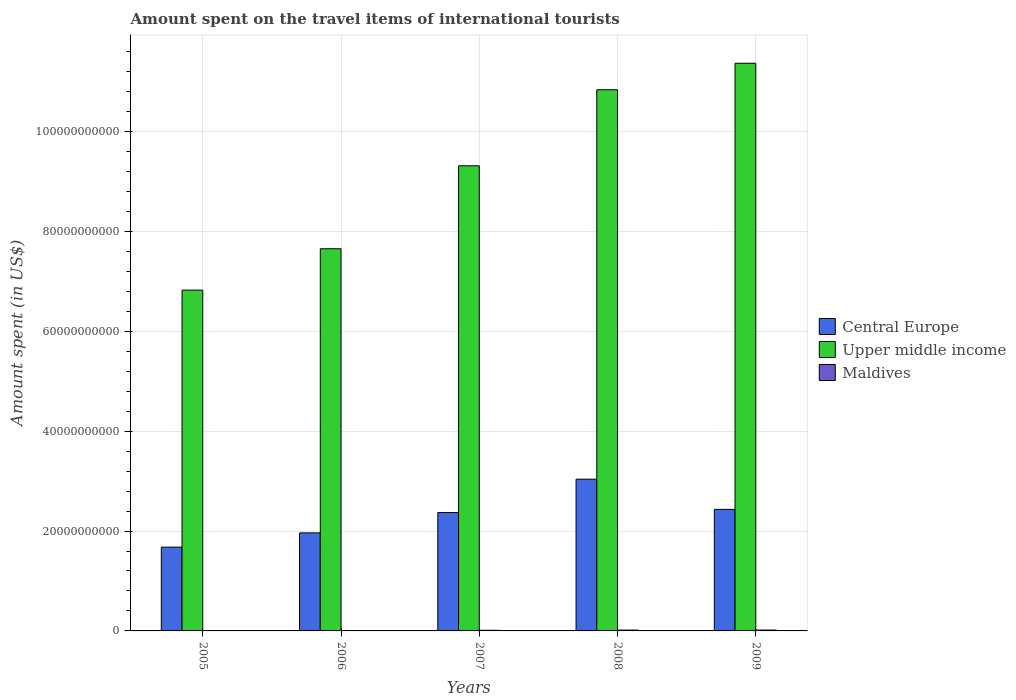How many different coloured bars are there?
Provide a succinct answer. 3. How many groups of bars are there?
Make the answer very short. 5. What is the amount spent on the travel items of international tourists in Central Europe in 2006?
Give a very brief answer. 1.96e+1. Across all years, what is the maximum amount spent on the travel items of international tourists in Maldives?
Keep it short and to the point. 1.74e+08. Across all years, what is the minimum amount spent on the travel items of international tourists in Upper middle income?
Offer a very short reply. 6.82e+1. In which year was the amount spent on the travel items of international tourists in Central Europe minimum?
Offer a terse response. 2005. What is the total amount spent on the travel items of international tourists in Upper middle income in the graph?
Your answer should be very brief. 4.60e+11. What is the difference between the amount spent on the travel items of international tourists in Upper middle income in 2008 and that in 2009?
Keep it short and to the point. -5.30e+09. What is the difference between the amount spent on the travel items of international tourists in Upper middle income in 2005 and the amount spent on the travel items of international tourists in Central Europe in 2009?
Offer a very short reply. 4.39e+1. What is the average amount spent on the travel items of international tourists in Maldives per year?
Provide a short and direct response. 1.22e+08. In the year 2009, what is the difference between the amount spent on the travel items of international tourists in Maldives and amount spent on the travel items of international tourists in Central Europe?
Offer a very short reply. -2.42e+1. In how many years, is the amount spent on the travel items of international tourists in Upper middle income greater than 96000000000 US$?
Give a very brief answer. 2. What is the ratio of the amount spent on the travel items of international tourists in Maldives in 2006 to that in 2008?
Offer a very short reply. 0.47. Is the amount spent on the travel items of international tourists in Upper middle income in 2006 less than that in 2007?
Your answer should be very brief. Yes. What is the difference between the highest and the lowest amount spent on the travel items of international tourists in Upper middle income?
Ensure brevity in your answer.  4.54e+1. Is the sum of the amount spent on the travel items of international tourists in Central Europe in 2006 and 2009 greater than the maximum amount spent on the travel items of international tourists in Upper middle income across all years?
Provide a short and direct response. No. What does the 2nd bar from the left in 2009 represents?
Your answer should be compact. Upper middle income. What does the 3rd bar from the right in 2006 represents?
Keep it short and to the point. Central Europe. Is it the case that in every year, the sum of the amount spent on the travel items of international tourists in Central Europe and amount spent on the travel items of international tourists in Maldives is greater than the amount spent on the travel items of international tourists in Upper middle income?
Provide a short and direct response. No. How many bars are there?
Keep it short and to the point. 15. Are all the bars in the graph horizontal?
Your response must be concise. No. How many years are there in the graph?
Ensure brevity in your answer.  5. What is the difference between two consecutive major ticks on the Y-axis?
Your answer should be compact. 2.00e+1. Are the values on the major ticks of Y-axis written in scientific E-notation?
Provide a succinct answer. No. Does the graph contain grids?
Provide a succinct answer. Yes. What is the title of the graph?
Keep it short and to the point. Amount spent on the travel items of international tourists. Does "Arab World" appear as one of the legend labels in the graph?
Make the answer very short. No. What is the label or title of the X-axis?
Your answer should be very brief. Years. What is the label or title of the Y-axis?
Make the answer very short. Amount spent (in US$). What is the Amount spent (in US$) of Central Europe in 2005?
Keep it short and to the point. 1.68e+1. What is the Amount spent (in US$) of Upper middle income in 2005?
Your response must be concise. 6.82e+1. What is the Amount spent (in US$) in Maldives in 2005?
Offer a terse response. 7.00e+07. What is the Amount spent (in US$) of Central Europe in 2006?
Your answer should be very brief. 1.96e+1. What is the Amount spent (in US$) in Upper middle income in 2006?
Your response must be concise. 7.65e+1. What is the Amount spent (in US$) of Maldives in 2006?
Provide a short and direct response. 7.80e+07. What is the Amount spent (in US$) of Central Europe in 2007?
Ensure brevity in your answer.  2.37e+1. What is the Amount spent (in US$) of Upper middle income in 2007?
Make the answer very short. 9.31e+1. What is the Amount spent (in US$) of Maldives in 2007?
Your answer should be very brief. 1.22e+08. What is the Amount spent (in US$) in Central Europe in 2008?
Give a very brief answer. 3.04e+1. What is the Amount spent (in US$) of Upper middle income in 2008?
Offer a very short reply. 1.08e+11. What is the Amount spent (in US$) in Maldives in 2008?
Ensure brevity in your answer.  1.67e+08. What is the Amount spent (in US$) in Central Europe in 2009?
Your answer should be compact. 2.43e+1. What is the Amount spent (in US$) in Upper middle income in 2009?
Provide a succinct answer. 1.14e+11. What is the Amount spent (in US$) of Maldives in 2009?
Your answer should be compact. 1.74e+08. Across all years, what is the maximum Amount spent (in US$) in Central Europe?
Provide a succinct answer. 3.04e+1. Across all years, what is the maximum Amount spent (in US$) in Upper middle income?
Provide a short and direct response. 1.14e+11. Across all years, what is the maximum Amount spent (in US$) of Maldives?
Ensure brevity in your answer.  1.74e+08. Across all years, what is the minimum Amount spent (in US$) in Central Europe?
Make the answer very short. 1.68e+1. Across all years, what is the minimum Amount spent (in US$) in Upper middle income?
Keep it short and to the point. 6.82e+1. Across all years, what is the minimum Amount spent (in US$) of Maldives?
Ensure brevity in your answer.  7.00e+07. What is the total Amount spent (in US$) of Central Europe in the graph?
Provide a succinct answer. 1.15e+11. What is the total Amount spent (in US$) in Upper middle income in the graph?
Provide a short and direct response. 4.60e+11. What is the total Amount spent (in US$) in Maldives in the graph?
Offer a very short reply. 6.11e+08. What is the difference between the Amount spent (in US$) of Central Europe in 2005 and that in 2006?
Keep it short and to the point. -2.85e+09. What is the difference between the Amount spent (in US$) in Upper middle income in 2005 and that in 2006?
Keep it short and to the point. -8.28e+09. What is the difference between the Amount spent (in US$) in Maldives in 2005 and that in 2006?
Your answer should be compact. -8.00e+06. What is the difference between the Amount spent (in US$) in Central Europe in 2005 and that in 2007?
Offer a terse response. -6.92e+09. What is the difference between the Amount spent (in US$) in Upper middle income in 2005 and that in 2007?
Provide a short and direct response. -2.49e+1. What is the difference between the Amount spent (in US$) of Maldives in 2005 and that in 2007?
Provide a succinct answer. -5.20e+07. What is the difference between the Amount spent (in US$) of Central Europe in 2005 and that in 2008?
Your answer should be compact. -1.36e+1. What is the difference between the Amount spent (in US$) of Upper middle income in 2005 and that in 2008?
Your answer should be very brief. -4.01e+1. What is the difference between the Amount spent (in US$) of Maldives in 2005 and that in 2008?
Your answer should be compact. -9.70e+07. What is the difference between the Amount spent (in US$) in Central Europe in 2005 and that in 2009?
Your answer should be very brief. -7.56e+09. What is the difference between the Amount spent (in US$) of Upper middle income in 2005 and that in 2009?
Your answer should be compact. -4.54e+1. What is the difference between the Amount spent (in US$) of Maldives in 2005 and that in 2009?
Provide a short and direct response. -1.04e+08. What is the difference between the Amount spent (in US$) in Central Europe in 2006 and that in 2007?
Give a very brief answer. -4.08e+09. What is the difference between the Amount spent (in US$) of Upper middle income in 2006 and that in 2007?
Offer a terse response. -1.66e+1. What is the difference between the Amount spent (in US$) in Maldives in 2006 and that in 2007?
Your answer should be compact. -4.40e+07. What is the difference between the Amount spent (in US$) in Central Europe in 2006 and that in 2008?
Your response must be concise. -1.08e+1. What is the difference between the Amount spent (in US$) of Upper middle income in 2006 and that in 2008?
Your answer should be compact. -3.18e+1. What is the difference between the Amount spent (in US$) in Maldives in 2006 and that in 2008?
Your answer should be very brief. -8.90e+07. What is the difference between the Amount spent (in US$) in Central Europe in 2006 and that in 2009?
Your answer should be very brief. -4.71e+09. What is the difference between the Amount spent (in US$) of Upper middle income in 2006 and that in 2009?
Provide a short and direct response. -3.71e+1. What is the difference between the Amount spent (in US$) in Maldives in 2006 and that in 2009?
Give a very brief answer. -9.60e+07. What is the difference between the Amount spent (in US$) of Central Europe in 2007 and that in 2008?
Your answer should be very brief. -6.68e+09. What is the difference between the Amount spent (in US$) in Upper middle income in 2007 and that in 2008?
Provide a short and direct response. -1.52e+1. What is the difference between the Amount spent (in US$) of Maldives in 2007 and that in 2008?
Your answer should be compact. -4.50e+07. What is the difference between the Amount spent (in US$) of Central Europe in 2007 and that in 2009?
Your answer should be very brief. -6.36e+08. What is the difference between the Amount spent (in US$) of Upper middle income in 2007 and that in 2009?
Your answer should be compact. -2.05e+1. What is the difference between the Amount spent (in US$) in Maldives in 2007 and that in 2009?
Your response must be concise. -5.20e+07. What is the difference between the Amount spent (in US$) in Central Europe in 2008 and that in 2009?
Your response must be concise. 6.05e+09. What is the difference between the Amount spent (in US$) in Upper middle income in 2008 and that in 2009?
Offer a terse response. -5.30e+09. What is the difference between the Amount spent (in US$) of Maldives in 2008 and that in 2009?
Make the answer very short. -7.00e+06. What is the difference between the Amount spent (in US$) of Central Europe in 2005 and the Amount spent (in US$) of Upper middle income in 2006?
Give a very brief answer. -5.97e+1. What is the difference between the Amount spent (in US$) of Central Europe in 2005 and the Amount spent (in US$) of Maldives in 2006?
Provide a succinct answer. 1.67e+1. What is the difference between the Amount spent (in US$) of Upper middle income in 2005 and the Amount spent (in US$) of Maldives in 2006?
Provide a succinct answer. 6.82e+1. What is the difference between the Amount spent (in US$) in Central Europe in 2005 and the Amount spent (in US$) in Upper middle income in 2007?
Keep it short and to the point. -7.64e+1. What is the difference between the Amount spent (in US$) of Central Europe in 2005 and the Amount spent (in US$) of Maldives in 2007?
Give a very brief answer. 1.67e+1. What is the difference between the Amount spent (in US$) in Upper middle income in 2005 and the Amount spent (in US$) in Maldives in 2007?
Your answer should be very brief. 6.81e+1. What is the difference between the Amount spent (in US$) of Central Europe in 2005 and the Amount spent (in US$) of Upper middle income in 2008?
Your answer should be very brief. -9.16e+1. What is the difference between the Amount spent (in US$) of Central Europe in 2005 and the Amount spent (in US$) of Maldives in 2008?
Your answer should be very brief. 1.66e+1. What is the difference between the Amount spent (in US$) of Upper middle income in 2005 and the Amount spent (in US$) of Maldives in 2008?
Your answer should be compact. 6.81e+1. What is the difference between the Amount spent (in US$) in Central Europe in 2005 and the Amount spent (in US$) in Upper middle income in 2009?
Offer a terse response. -9.69e+1. What is the difference between the Amount spent (in US$) of Central Europe in 2005 and the Amount spent (in US$) of Maldives in 2009?
Offer a terse response. 1.66e+1. What is the difference between the Amount spent (in US$) in Upper middle income in 2005 and the Amount spent (in US$) in Maldives in 2009?
Keep it short and to the point. 6.81e+1. What is the difference between the Amount spent (in US$) in Central Europe in 2006 and the Amount spent (in US$) in Upper middle income in 2007?
Your answer should be compact. -7.35e+1. What is the difference between the Amount spent (in US$) of Central Europe in 2006 and the Amount spent (in US$) of Maldives in 2007?
Your answer should be compact. 1.95e+1. What is the difference between the Amount spent (in US$) of Upper middle income in 2006 and the Amount spent (in US$) of Maldives in 2007?
Provide a succinct answer. 7.64e+1. What is the difference between the Amount spent (in US$) in Central Europe in 2006 and the Amount spent (in US$) in Upper middle income in 2008?
Ensure brevity in your answer.  -8.87e+1. What is the difference between the Amount spent (in US$) of Central Europe in 2006 and the Amount spent (in US$) of Maldives in 2008?
Offer a very short reply. 1.95e+1. What is the difference between the Amount spent (in US$) of Upper middle income in 2006 and the Amount spent (in US$) of Maldives in 2008?
Offer a very short reply. 7.64e+1. What is the difference between the Amount spent (in US$) in Central Europe in 2006 and the Amount spent (in US$) in Upper middle income in 2009?
Your answer should be compact. -9.40e+1. What is the difference between the Amount spent (in US$) of Central Europe in 2006 and the Amount spent (in US$) of Maldives in 2009?
Provide a short and direct response. 1.95e+1. What is the difference between the Amount spent (in US$) in Upper middle income in 2006 and the Amount spent (in US$) in Maldives in 2009?
Your answer should be very brief. 7.63e+1. What is the difference between the Amount spent (in US$) of Central Europe in 2007 and the Amount spent (in US$) of Upper middle income in 2008?
Provide a succinct answer. -8.47e+1. What is the difference between the Amount spent (in US$) in Central Europe in 2007 and the Amount spent (in US$) in Maldives in 2008?
Provide a short and direct response. 2.35e+1. What is the difference between the Amount spent (in US$) of Upper middle income in 2007 and the Amount spent (in US$) of Maldives in 2008?
Provide a succinct answer. 9.30e+1. What is the difference between the Amount spent (in US$) of Central Europe in 2007 and the Amount spent (in US$) of Upper middle income in 2009?
Offer a terse response. -9.00e+1. What is the difference between the Amount spent (in US$) in Central Europe in 2007 and the Amount spent (in US$) in Maldives in 2009?
Your response must be concise. 2.35e+1. What is the difference between the Amount spent (in US$) of Upper middle income in 2007 and the Amount spent (in US$) of Maldives in 2009?
Offer a terse response. 9.30e+1. What is the difference between the Amount spent (in US$) in Central Europe in 2008 and the Amount spent (in US$) in Upper middle income in 2009?
Provide a succinct answer. -8.33e+1. What is the difference between the Amount spent (in US$) in Central Europe in 2008 and the Amount spent (in US$) in Maldives in 2009?
Provide a short and direct response. 3.02e+1. What is the difference between the Amount spent (in US$) in Upper middle income in 2008 and the Amount spent (in US$) in Maldives in 2009?
Your response must be concise. 1.08e+11. What is the average Amount spent (in US$) in Central Europe per year?
Make the answer very short. 2.30e+1. What is the average Amount spent (in US$) of Upper middle income per year?
Offer a very short reply. 9.20e+1. What is the average Amount spent (in US$) of Maldives per year?
Your answer should be very brief. 1.22e+08. In the year 2005, what is the difference between the Amount spent (in US$) in Central Europe and Amount spent (in US$) in Upper middle income?
Keep it short and to the point. -5.15e+1. In the year 2005, what is the difference between the Amount spent (in US$) in Central Europe and Amount spent (in US$) in Maldives?
Offer a very short reply. 1.67e+1. In the year 2005, what is the difference between the Amount spent (in US$) in Upper middle income and Amount spent (in US$) in Maldives?
Your answer should be very brief. 6.82e+1. In the year 2006, what is the difference between the Amount spent (in US$) in Central Europe and Amount spent (in US$) in Upper middle income?
Offer a very short reply. -5.69e+1. In the year 2006, what is the difference between the Amount spent (in US$) of Central Europe and Amount spent (in US$) of Maldives?
Provide a succinct answer. 1.95e+1. In the year 2006, what is the difference between the Amount spent (in US$) of Upper middle income and Amount spent (in US$) of Maldives?
Provide a succinct answer. 7.64e+1. In the year 2007, what is the difference between the Amount spent (in US$) of Central Europe and Amount spent (in US$) of Upper middle income?
Provide a short and direct response. -6.94e+1. In the year 2007, what is the difference between the Amount spent (in US$) of Central Europe and Amount spent (in US$) of Maldives?
Your response must be concise. 2.36e+1. In the year 2007, what is the difference between the Amount spent (in US$) of Upper middle income and Amount spent (in US$) of Maldives?
Your response must be concise. 9.30e+1. In the year 2008, what is the difference between the Amount spent (in US$) of Central Europe and Amount spent (in US$) of Upper middle income?
Give a very brief answer. -7.80e+1. In the year 2008, what is the difference between the Amount spent (in US$) of Central Europe and Amount spent (in US$) of Maldives?
Your response must be concise. 3.02e+1. In the year 2008, what is the difference between the Amount spent (in US$) in Upper middle income and Amount spent (in US$) in Maldives?
Offer a terse response. 1.08e+11. In the year 2009, what is the difference between the Amount spent (in US$) in Central Europe and Amount spent (in US$) in Upper middle income?
Keep it short and to the point. -8.93e+1. In the year 2009, what is the difference between the Amount spent (in US$) in Central Europe and Amount spent (in US$) in Maldives?
Provide a short and direct response. 2.42e+1. In the year 2009, what is the difference between the Amount spent (in US$) of Upper middle income and Amount spent (in US$) of Maldives?
Ensure brevity in your answer.  1.13e+11. What is the ratio of the Amount spent (in US$) of Central Europe in 2005 to that in 2006?
Your answer should be very brief. 0.85. What is the ratio of the Amount spent (in US$) of Upper middle income in 2005 to that in 2006?
Keep it short and to the point. 0.89. What is the ratio of the Amount spent (in US$) in Maldives in 2005 to that in 2006?
Offer a very short reply. 0.9. What is the ratio of the Amount spent (in US$) in Central Europe in 2005 to that in 2007?
Your answer should be compact. 0.71. What is the ratio of the Amount spent (in US$) in Upper middle income in 2005 to that in 2007?
Your answer should be compact. 0.73. What is the ratio of the Amount spent (in US$) in Maldives in 2005 to that in 2007?
Offer a very short reply. 0.57. What is the ratio of the Amount spent (in US$) in Central Europe in 2005 to that in 2008?
Provide a succinct answer. 0.55. What is the ratio of the Amount spent (in US$) of Upper middle income in 2005 to that in 2008?
Keep it short and to the point. 0.63. What is the ratio of the Amount spent (in US$) of Maldives in 2005 to that in 2008?
Provide a short and direct response. 0.42. What is the ratio of the Amount spent (in US$) in Central Europe in 2005 to that in 2009?
Provide a succinct answer. 0.69. What is the ratio of the Amount spent (in US$) of Upper middle income in 2005 to that in 2009?
Make the answer very short. 0.6. What is the ratio of the Amount spent (in US$) of Maldives in 2005 to that in 2009?
Your answer should be very brief. 0.4. What is the ratio of the Amount spent (in US$) of Central Europe in 2006 to that in 2007?
Your response must be concise. 0.83. What is the ratio of the Amount spent (in US$) of Upper middle income in 2006 to that in 2007?
Keep it short and to the point. 0.82. What is the ratio of the Amount spent (in US$) of Maldives in 2006 to that in 2007?
Keep it short and to the point. 0.64. What is the ratio of the Amount spent (in US$) of Central Europe in 2006 to that in 2008?
Ensure brevity in your answer.  0.65. What is the ratio of the Amount spent (in US$) of Upper middle income in 2006 to that in 2008?
Your response must be concise. 0.71. What is the ratio of the Amount spent (in US$) of Maldives in 2006 to that in 2008?
Ensure brevity in your answer.  0.47. What is the ratio of the Amount spent (in US$) of Central Europe in 2006 to that in 2009?
Provide a short and direct response. 0.81. What is the ratio of the Amount spent (in US$) of Upper middle income in 2006 to that in 2009?
Your answer should be very brief. 0.67. What is the ratio of the Amount spent (in US$) of Maldives in 2006 to that in 2009?
Make the answer very short. 0.45. What is the ratio of the Amount spent (in US$) in Central Europe in 2007 to that in 2008?
Keep it short and to the point. 0.78. What is the ratio of the Amount spent (in US$) in Upper middle income in 2007 to that in 2008?
Your response must be concise. 0.86. What is the ratio of the Amount spent (in US$) in Maldives in 2007 to that in 2008?
Keep it short and to the point. 0.73. What is the ratio of the Amount spent (in US$) in Central Europe in 2007 to that in 2009?
Your answer should be very brief. 0.97. What is the ratio of the Amount spent (in US$) in Upper middle income in 2007 to that in 2009?
Give a very brief answer. 0.82. What is the ratio of the Amount spent (in US$) in Maldives in 2007 to that in 2009?
Your answer should be compact. 0.7. What is the ratio of the Amount spent (in US$) of Central Europe in 2008 to that in 2009?
Ensure brevity in your answer.  1.25. What is the ratio of the Amount spent (in US$) in Upper middle income in 2008 to that in 2009?
Offer a terse response. 0.95. What is the ratio of the Amount spent (in US$) of Maldives in 2008 to that in 2009?
Give a very brief answer. 0.96. What is the difference between the highest and the second highest Amount spent (in US$) of Central Europe?
Your answer should be compact. 6.05e+09. What is the difference between the highest and the second highest Amount spent (in US$) of Upper middle income?
Your response must be concise. 5.30e+09. What is the difference between the highest and the second highest Amount spent (in US$) of Maldives?
Offer a very short reply. 7.00e+06. What is the difference between the highest and the lowest Amount spent (in US$) in Central Europe?
Provide a short and direct response. 1.36e+1. What is the difference between the highest and the lowest Amount spent (in US$) in Upper middle income?
Provide a short and direct response. 4.54e+1. What is the difference between the highest and the lowest Amount spent (in US$) of Maldives?
Keep it short and to the point. 1.04e+08. 